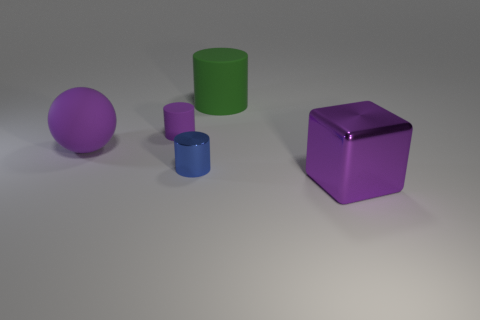Are there fewer small blue shiny cylinders behind the big purple matte object than big objects to the right of the small blue metal thing?
Your answer should be compact. Yes. There is a big purple object behind the large purple thing that is in front of the large purple rubber object; what shape is it?
Ensure brevity in your answer.  Sphere. Is there any other thing of the same color as the large sphere?
Offer a very short reply. Yes. Is the color of the large rubber ball the same as the tiny matte cylinder?
Provide a succinct answer. Yes. What number of green things are either metal objects or large matte objects?
Provide a short and direct response. 1. Are there fewer large rubber cylinders that are in front of the large purple matte ball than large green rubber objects?
Keep it short and to the point. Yes. There is a big rubber object that is right of the tiny purple thing; how many purple metal cubes are in front of it?
Provide a succinct answer. 1. How many other objects are the same size as the ball?
Make the answer very short. 2. How many objects are small blue objects or things that are behind the tiny blue thing?
Provide a short and direct response. 4. Is the number of big gray matte cylinders less than the number of purple blocks?
Your answer should be very brief. Yes. 